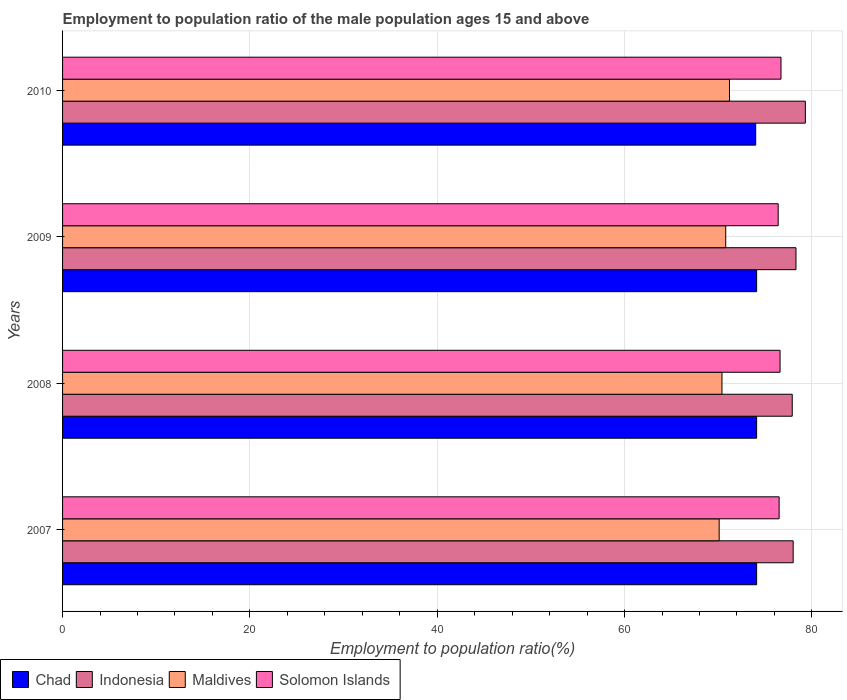How many groups of bars are there?
Offer a terse response. 4. Are the number of bars per tick equal to the number of legend labels?
Provide a short and direct response. Yes. Are the number of bars on each tick of the Y-axis equal?
Give a very brief answer. Yes. How many bars are there on the 1st tick from the top?
Give a very brief answer. 4. How many bars are there on the 3rd tick from the bottom?
Your answer should be very brief. 4. What is the employment to population ratio in Maldives in 2010?
Make the answer very short. 71.2. Across all years, what is the maximum employment to population ratio in Chad?
Your response must be concise. 74.1. Across all years, what is the minimum employment to population ratio in Maldives?
Offer a terse response. 70.1. In which year was the employment to population ratio in Maldives maximum?
Your response must be concise. 2010. What is the total employment to population ratio in Maldives in the graph?
Your answer should be compact. 282.5. What is the difference between the employment to population ratio in Maldives in 2008 and that in 2010?
Your response must be concise. -0.8. What is the difference between the employment to population ratio in Solomon Islands in 2010 and the employment to population ratio in Indonesia in 2007?
Your response must be concise. -1.3. What is the average employment to population ratio in Indonesia per year?
Your answer should be compact. 78.38. In the year 2009, what is the difference between the employment to population ratio in Indonesia and employment to population ratio in Solomon Islands?
Provide a short and direct response. 1.9. In how many years, is the employment to population ratio in Solomon Islands greater than 52 %?
Keep it short and to the point. 4. What is the ratio of the employment to population ratio in Maldives in 2008 to that in 2010?
Provide a succinct answer. 0.99. Is the employment to population ratio in Maldives in 2008 less than that in 2009?
Offer a very short reply. Yes. What is the difference between the highest and the second highest employment to population ratio in Indonesia?
Ensure brevity in your answer.  1. What is the difference between the highest and the lowest employment to population ratio in Solomon Islands?
Give a very brief answer. 0.3. Is it the case that in every year, the sum of the employment to population ratio in Chad and employment to population ratio in Maldives is greater than the sum of employment to population ratio in Solomon Islands and employment to population ratio in Indonesia?
Provide a succinct answer. No. What does the 1st bar from the top in 2007 represents?
Offer a very short reply. Solomon Islands. What does the 4th bar from the bottom in 2010 represents?
Offer a terse response. Solomon Islands. Are all the bars in the graph horizontal?
Ensure brevity in your answer.  Yes. What is the difference between two consecutive major ticks on the X-axis?
Your answer should be very brief. 20. Where does the legend appear in the graph?
Ensure brevity in your answer.  Bottom left. How many legend labels are there?
Offer a very short reply. 4. How are the legend labels stacked?
Your answer should be very brief. Horizontal. What is the title of the graph?
Your answer should be compact. Employment to population ratio of the male population ages 15 and above. What is the label or title of the Y-axis?
Provide a short and direct response. Years. What is the Employment to population ratio(%) in Chad in 2007?
Your answer should be very brief. 74.1. What is the Employment to population ratio(%) in Maldives in 2007?
Provide a succinct answer. 70.1. What is the Employment to population ratio(%) in Solomon Islands in 2007?
Your answer should be very brief. 76.5. What is the Employment to population ratio(%) in Chad in 2008?
Offer a terse response. 74.1. What is the Employment to population ratio(%) of Indonesia in 2008?
Ensure brevity in your answer.  77.9. What is the Employment to population ratio(%) of Maldives in 2008?
Provide a short and direct response. 70.4. What is the Employment to population ratio(%) of Solomon Islands in 2008?
Provide a short and direct response. 76.6. What is the Employment to population ratio(%) in Chad in 2009?
Make the answer very short. 74.1. What is the Employment to population ratio(%) of Indonesia in 2009?
Give a very brief answer. 78.3. What is the Employment to population ratio(%) in Maldives in 2009?
Provide a short and direct response. 70.8. What is the Employment to population ratio(%) in Solomon Islands in 2009?
Your response must be concise. 76.4. What is the Employment to population ratio(%) of Chad in 2010?
Provide a short and direct response. 74. What is the Employment to population ratio(%) of Indonesia in 2010?
Give a very brief answer. 79.3. What is the Employment to population ratio(%) of Maldives in 2010?
Provide a short and direct response. 71.2. What is the Employment to population ratio(%) of Solomon Islands in 2010?
Your answer should be very brief. 76.7. Across all years, what is the maximum Employment to population ratio(%) of Chad?
Provide a short and direct response. 74.1. Across all years, what is the maximum Employment to population ratio(%) in Indonesia?
Provide a succinct answer. 79.3. Across all years, what is the maximum Employment to population ratio(%) of Maldives?
Give a very brief answer. 71.2. Across all years, what is the maximum Employment to population ratio(%) in Solomon Islands?
Provide a short and direct response. 76.7. Across all years, what is the minimum Employment to population ratio(%) of Indonesia?
Give a very brief answer. 77.9. Across all years, what is the minimum Employment to population ratio(%) of Maldives?
Keep it short and to the point. 70.1. Across all years, what is the minimum Employment to population ratio(%) in Solomon Islands?
Your answer should be compact. 76.4. What is the total Employment to population ratio(%) of Chad in the graph?
Ensure brevity in your answer.  296.3. What is the total Employment to population ratio(%) in Indonesia in the graph?
Your answer should be compact. 313.5. What is the total Employment to population ratio(%) in Maldives in the graph?
Your answer should be very brief. 282.5. What is the total Employment to population ratio(%) in Solomon Islands in the graph?
Make the answer very short. 306.2. What is the difference between the Employment to population ratio(%) of Maldives in 2007 and that in 2009?
Your answer should be very brief. -0.7. What is the difference between the Employment to population ratio(%) in Solomon Islands in 2007 and that in 2009?
Provide a succinct answer. 0.1. What is the difference between the Employment to population ratio(%) of Chad in 2007 and that in 2010?
Keep it short and to the point. 0.1. What is the difference between the Employment to population ratio(%) of Indonesia in 2007 and that in 2010?
Your answer should be very brief. -1.3. What is the difference between the Employment to population ratio(%) of Maldives in 2007 and that in 2010?
Your answer should be compact. -1.1. What is the difference between the Employment to population ratio(%) of Solomon Islands in 2007 and that in 2010?
Your response must be concise. -0.2. What is the difference between the Employment to population ratio(%) of Indonesia in 2008 and that in 2009?
Keep it short and to the point. -0.4. What is the difference between the Employment to population ratio(%) of Chad in 2008 and that in 2010?
Provide a short and direct response. 0.1. What is the difference between the Employment to population ratio(%) of Indonesia in 2008 and that in 2010?
Offer a very short reply. -1.4. What is the difference between the Employment to population ratio(%) in Solomon Islands in 2008 and that in 2010?
Provide a succinct answer. -0.1. What is the difference between the Employment to population ratio(%) of Maldives in 2009 and that in 2010?
Offer a very short reply. -0.4. What is the difference between the Employment to population ratio(%) of Solomon Islands in 2009 and that in 2010?
Give a very brief answer. -0.3. What is the difference between the Employment to population ratio(%) of Chad in 2007 and the Employment to population ratio(%) of Indonesia in 2008?
Provide a succinct answer. -3.8. What is the difference between the Employment to population ratio(%) in Chad in 2007 and the Employment to population ratio(%) in Maldives in 2008?
Ensure brevity in your answer.  3.7. What is the difference between the Employment to population ratio(%) in Indonesia in 2007 and the Employment to population ratio(%) in Maldives in 2008?
Provide a succinct answer. 7.6. What is the difference between the Employment to population ratio(%) of Indonesia in 2007 and the Employment to population ratio(%) of Solomon Islands in 2008?
Offer a terse response. 1.4. What is the difference between the Employment to population ratio(%) in Maldives in 2007 and the Employment to population ratio(%) in Solomon Islands in 2008?
Your answer should be very brief. -6.5. What is the difference between the Employment to population ratio(%) in Chad in 2007 and the Employment to population ratio(%) in Maldives in 2009?
Provide a short and direct response. 3.3. What is the difference between the Employment to population ratio(%) in Chad in 2007 and the Employment to population ratio(%) in Solomon Islands in 2009?
Provide a succinct answer. -2.3. What is the difference between the Employment to population ratio(%) in Indonesia in 2007 and the Employment to population ratio(%) in Solomon Islands in 2009?
Your answer should be compact. 1.6. What is the difference between the Employment to population ratio(%) in Chad in 2007 and the Employment to population ratio(%) in Maldives in 2010?
Give a very brief answer. 2.9. What is the difference between the Employment to population ratio(%) of Chad in 2007 and the Employment to population ratio(%) of Solomon Islands in 2010?
Make the answer very short. -2.6. What is the difference between the Employment to population ratio(%) in Indonesia in 2007 and the Employment to population ratio(%) in Maldives in 2010?
Provide a short and direct response. 6.8. What is the difference between the Employment to population ratio(%) in Indonesia in 2007 and the Employment to population ratio(%) in Solomon Islands in 2010?
Provide a short and direct response. 1.3. What is the difference between the Employment to population ratio(%) of Maldives in 2007 and the Employment to population ratio(%) of Solomon Islands in 2010?
Give a very brief answer. -6.6. What is the difference between the Employment to population ratio(%) in Chad in 2008 and the Employment to population ratio(%) in Maldives in 2009?
Your answer should be very brief. 3.3. What is the difference between the Employment to population ratio(%) of Maldives in 2008 and the Employment to population ratio(%) of Solomon Islands in 2009?
Keep it short and to the point. -6. What is the difference between the Employment to population ratio(%) of Chad in 2008 and the Employment to population ratio(%) of Solomon Islands in 2010?
Provide a succinct answer. -2.6. What is the difference between the Employment to population ratio(%) in Indonesia in 2008 and the Employment to population ratio(%) in Maldives in 2010?
Your answer should be very brief. 6.7. What is the difference between the Employment to population ratio(%) in Chad in 2009 and the Employment to population ratio(%) in Indonesia in 2010?
Offer a terse response. -5.2. What is the average Employment to population ratio(%) in Chad per year?
Keep it short and to the point. 74.08. What is the average Employment to population ratio(%) in Indonesia per year?
Ensure brevity in your answer.  78.38. What is the average Employment to population ratio(%) in Maldives per year?
Your answer should be very brief. 70.62. What is the average Employment to population ratio(%) of Solomon Islands per year?
Ensure brevity in your answer.  76.55. In the year 2007, what is the difference between the Employment to population ratio(%) in Chad and Employment to population ratio(%) in Solomon Islands?
Your answer should be compact. -2.4. In the year 2007, what is the difference between the Employment to population ratio(%) of Maldives and Employment to population ratio(%) of Solomon Islands?
Provide a succinct answer. -6.4. In the year 2008, what is the difference between the Employment to population ratio(%) in Chad and Employment to population ratio(%) in Maldives?
Ensure brevity in your answer.  3.7. In the year 2008, what is the difference between the Employment to population ratio(%) of Indonesia and Employment to population ratio(%) of Maldives?
Give a very brief answer. 7.5. In the year 2008, what is the difference between the Employment to population ratio(%) in Indonesia and Employment to population ratio(%) in Solomon Islands?
Give a very brief answer. 1.3. In the year 2009, what is the difference between the Employment to population ratio(%) of Chad and Employment to population ratio(%) of Indonesia?
Offer a very short reply. -4.2. In the year 2009, what is the difference between the Employment to population ratio(%) of Chad and Employment to population ratio(%) of Maldives?
Your answer should be very brief. 3.3. In the year 2009, what is the difference between the Employment to population ratio(%) in Chad and Employment to population ratio(%) in Solomon Islands?
Your response must be concise. -2.3. In the year 2009, what is the difference between the Employment to population ratio(%) in Indonesia and Employment to population ratio(%) in Maldives?
Offer a very short reply. 7.5. In the year 2009, what is the difference between the Employment to population ratio(%) of Indonesia and Employment to population ratio(%) of Solomon Islands?
Ensure brevity in your answer.  1.9. In the year 2009, what is the difference between the Employment to population ratio(%) of Maldives and Employment to population ratio(%) of Solomon Islands?
Give a very brief answer. -5.6. In the year 2010, what is the difference between the Employment to population ratio(%) in Indonesia and Employment to population ratio(%) in Maldives?
Ensure brevity in your answer.  8.1. What is the ratio of the Employment to population ratio(%) of Indonesia in 2007 to that in 2008?
Provide a succinct answer. 1. What is the ratio of the Employment to population ratio(%) in Maldives in 2007 to that in 2008?
Your answer should be very brief. 1. What is the ratio of the Employment to population ratio(%) of Solomon Islands in 2007 to that in 2008?
Offer a very short reply. 1. What is the ratio of the Employment to population ratio(%) in Indonesia in 2007 to that in 2009?
Ensure brevity in your answer.  1. What is the ratio of the Employment to population ratio(%) of Chad in 2007 to that in 2010?
Give a very brief answer. 1. What is the ratio of the Employment to population ratio(%) of Indonesia in 2007 to that in 2010?
Give a very brief answer. 0.98. What is the ratio of the Employment to population ratio(%) of Maldives in 2007 to that in 2010?
Your answer should be compact. 0.98. What is the ratio of the Employment to population ratio(%) of Chad in 2008 to that in 2009?
Your response must be concise. 1. What is the ratio of the Employment to population ratio(%) of Solomon Islands in 2008 to that in 2009?
Provide a short and direct response. 1. What is the ratio of the Employment to population ratio(%) in Chad in 2008 to that in 2010?
Your answer should be very brief. 1. What is the ratio of the Employment to population ratio(%) of Indonesia in 2008 to that in 2010?
Your response must be concise. 0.98. What is the ratio of the Employment to population ratio(%) in Solomon Islands in 2008 to that in 2010?
Ensure brevity in your answer.  1. What is the ratio of the Employment to population ratio(%) of Indonesia in 2009 to that in 2010?
Give a very brief answer. 0.99. What is the ratio of the Employment to population ratio(%) of Solomon Islands in 2009 to that in 2010?
Your answer should be compact. 1. What is the difference between the highest and the second highest Employment to population ratio(%) of Chad?
Your answer should be very brief. 0. What is the difference between the highest and the second highest Employment to population ratio(%) in Indonesia?
Make the answer very short. 1. What is the difference between the highest and the lowest Employment to population ratio(%) in Chad?
Offer a terse response. 0.1. What is the difference between the highest and the lowest Employment to population ratio(%) in Indonesia?
Make the answer very short. 1.4. What is the difference between the highest and the lowest Employment to population ratio(%) of Maldives?
Ensure brevity in your answer.  1.1. What is the difference between the highest and the lowest Employment to population ratio(%) in Solomon Islands?
Ensure brevity in your answer.  0.3. 